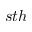Convert formula to latex. <formula><loc_0><loc_0><loc_500><loc_500>s t h</formula> 